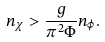<formula> <loc_0><loc_0><loc_500><loc_500>n _ { \chi } > \frac { g } { \pi ^ { 2 } \Phi } n _ { \varphi } .</formula> 